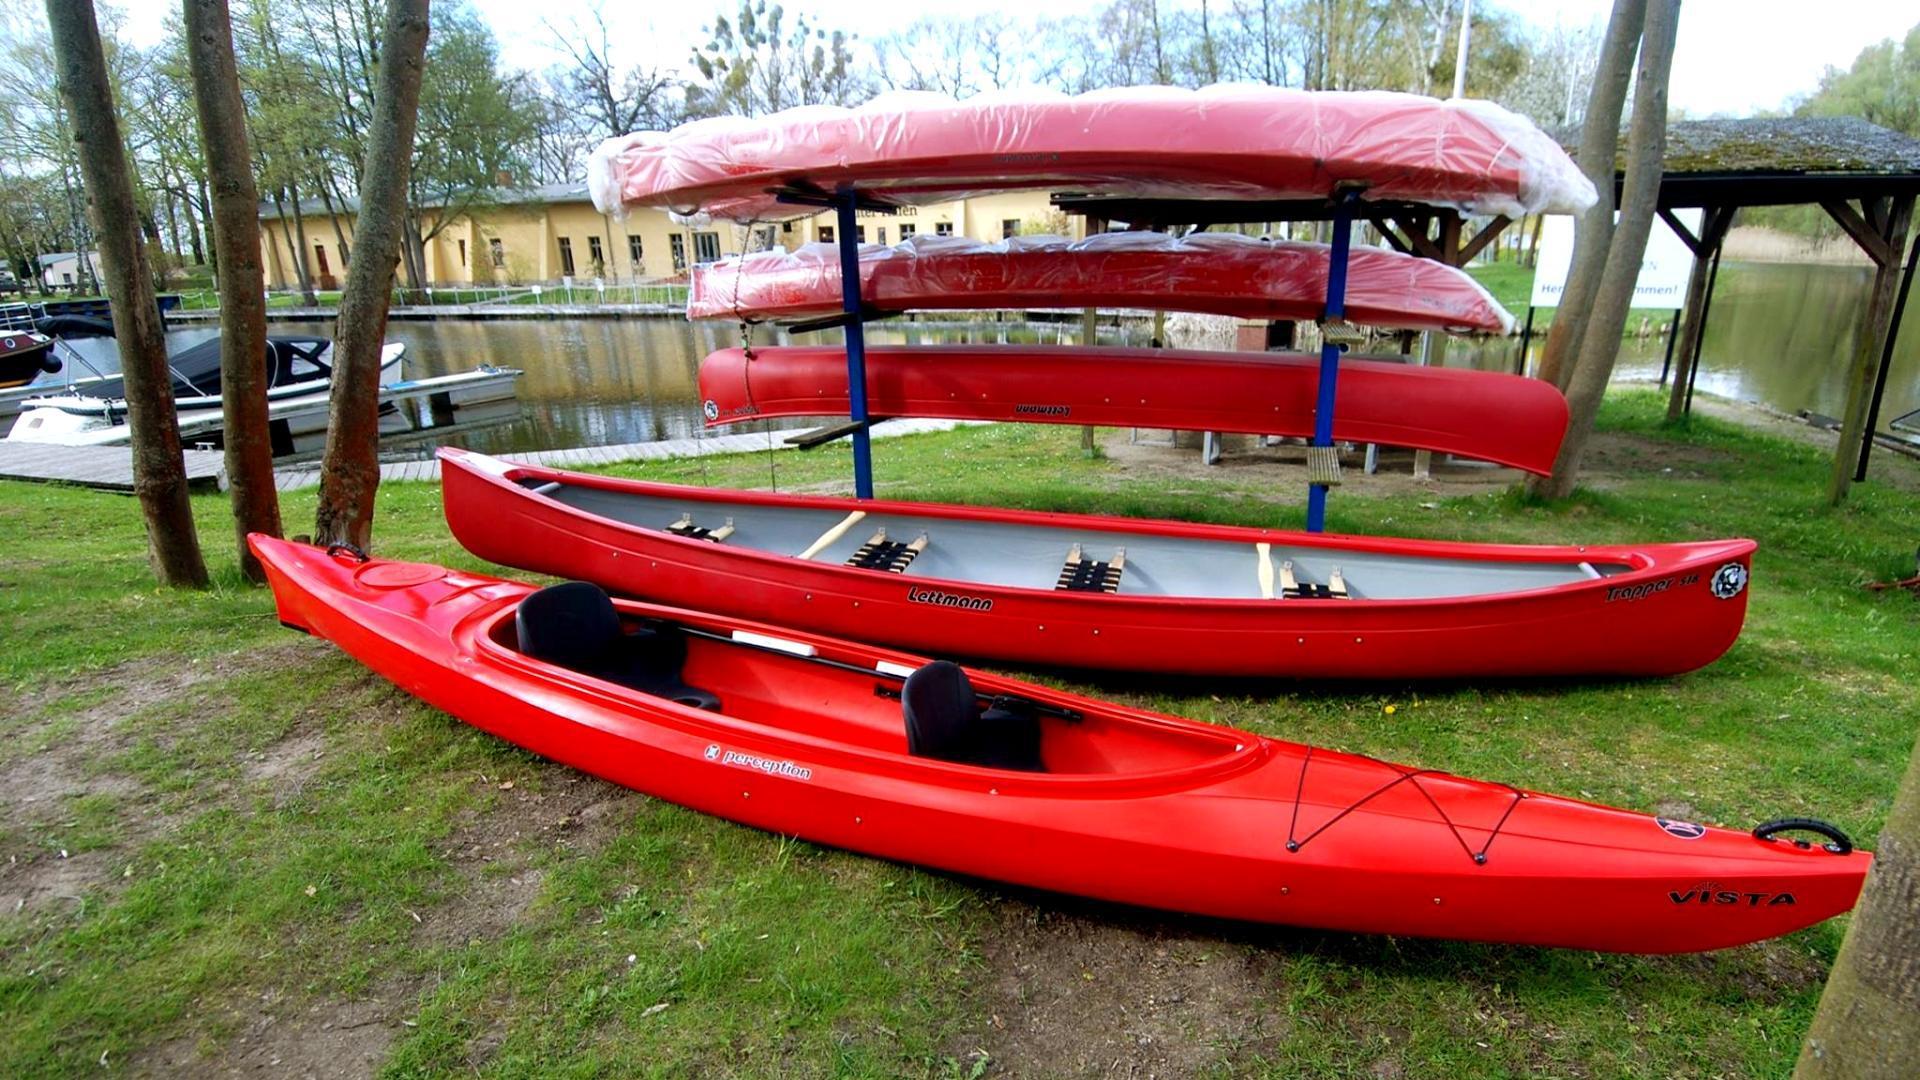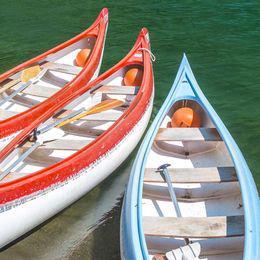The first image is the image on the left, the second image is the image on the right. Assess this claim about the two images: "An image shows a curving row of at least ten canoes, none containing humans.". Correct or not? Answer yes or no. No. The first image is the image on the left, the second image is the image on the right. Given the left and right images, does the statement "One of the images contain only one boat." hold true? Answer yes or no. No. 